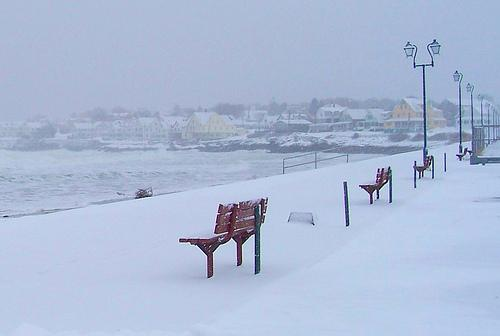Compose a poetic description of the scene in the image, capturing its winter essence and features. A hushed blanket of snow draped the world, softening edges along benches and paths, while lamp posts stood as silent sentinels in the glow of sweet golden windows, beckoning warmth from afar. Explain the climate conditions evident in the image, along with examples of how they affect the scene. The image depicts a snowy climate, with snow covering the ground, benches, walkway, buildings' roofs, and surrounding the water, creating a wintery atmosphere. Describe the image by mentioning its natural elements, such as water and snow, along with any man-made structures. The image showcases a snowy landscape mingled with water near the benches, red benches with green poles, lamp posts, yellow and orange buildings, and a railing leading down to the water. List three prominent objects in the image and briefly describe them, including their appearance and location. 3. Lamp posts - tall, dark, and featuring two lights, located near the benches and over the walkway. Write a brief overview of the scene, focusing on the major elements present. The scene features a snow-covered neighborhood with buildings, red benches, lamp posts, a railing by the water, and a fence near the benches. Mention the environment depicted in the image and the main feature related to it. The image shows a snowy environment with white snow covering the ground, benches, walkway, and roofs of nearby houses. Create a brief story inspired by the scene depicted in the image. On a tranquil winter day, snow has blanketed a quiet neighborhood near the water. Lamp posts illuminate the red benches and snow-covered walkway, while homes aglow with warmth rest in the distance. Describe the overall feel and atmosphere of the image based on the objects and scenery present. The image has a serene and wintery atmosphere, with snow covering the ground, benches, walkway, roofs, and even the rocks along with the water. Describe the structures and objects visible in the image, focusing on their colors and materials. In the image, there are yellow and orange buildings, red benches with green poles, dark lamp posts with two lights, a railing near the water, and a fence by the benches. Mention the main attraction in the image, and describe its features and surroundings. A row of red benches covered in snow serves as a striking focal point, surrounded by a snow-covered walkway, lamp posts, and green poles, with houses in the background. 